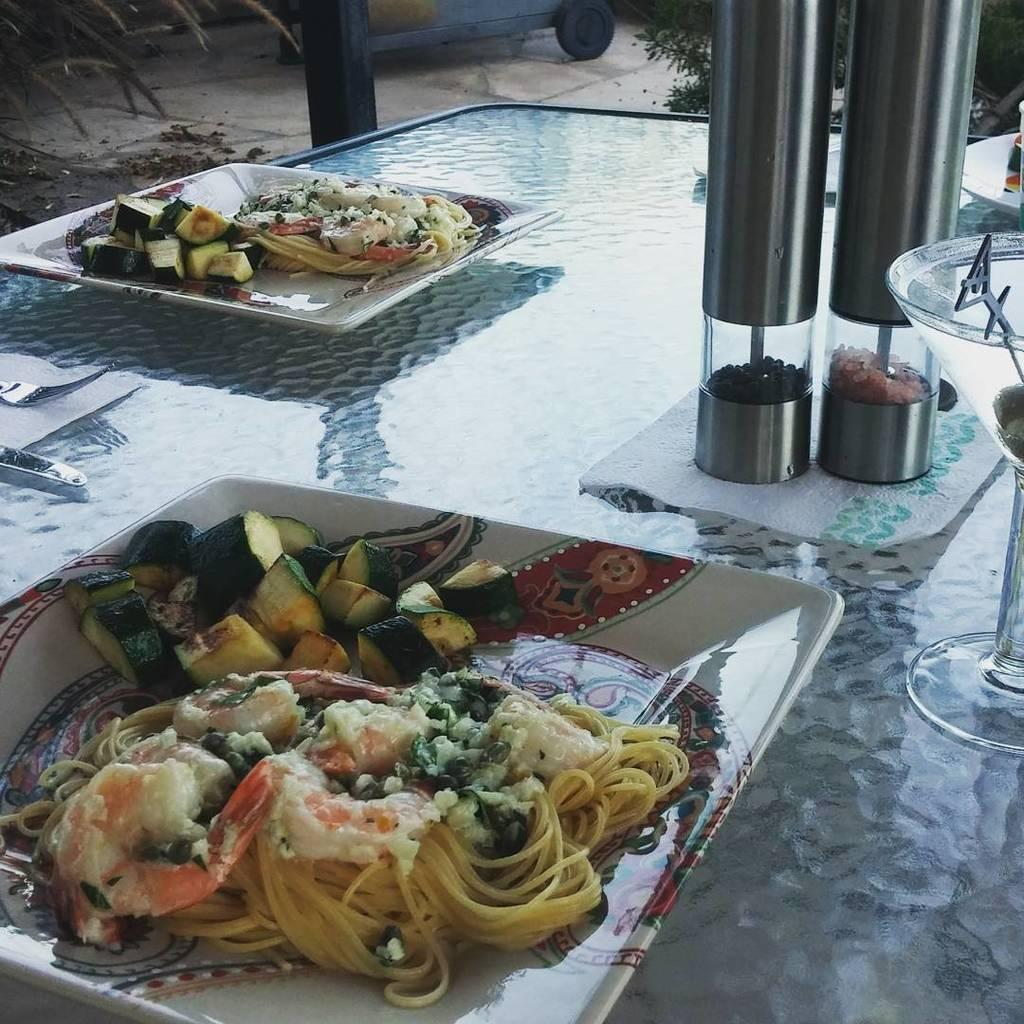What is the main piece of furniture in the image? There is a table in the image. What items are placed on the table? There are plates, glasses, and bottles on the table. What is on the plates? There is food on the plates. What else can be seen in the image besides the table and its contents? There is a vehicle, a plant, and a pole visible in the image. What type of box is being used as a territory marker in the image? There is no box or territory marker present in the image. What activity are the children participating in during recess in the image? There is no indication of children or a recess in the image. 